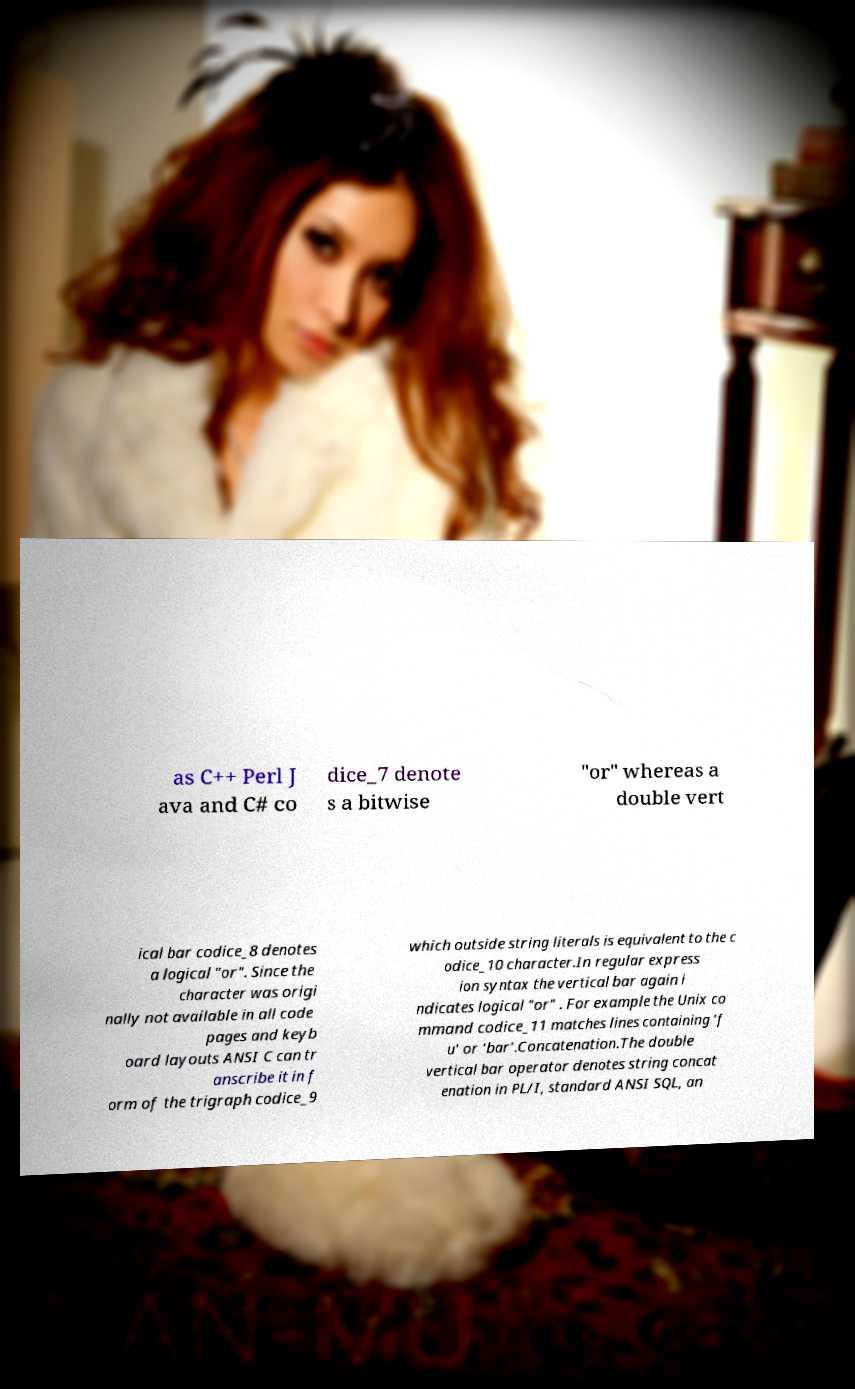What messages or text are displayed in this image? I need them in a readable, typed format. as C++ Perl J ava and C# co dice_7 denote s a bitwise "or" whereas a double vert ical bar codice_8 denotes a logical "or". Since the character was origi nally not available in all code pages and keyb oard layouts ANSI C can tr anscribe it in f orm of the trigraph codice_9 which outside string literals is equivalent to the c odice_10 character.In regular express ion syntax the vertical bar again i ndicates logical "or" . For example the Unix co mmand codice_11 matches lines containing 'f u' or 'bar'.Concatenation.The double vertical bar operator denotes string concat enation in PL/I, standard ANSI SQL, an 